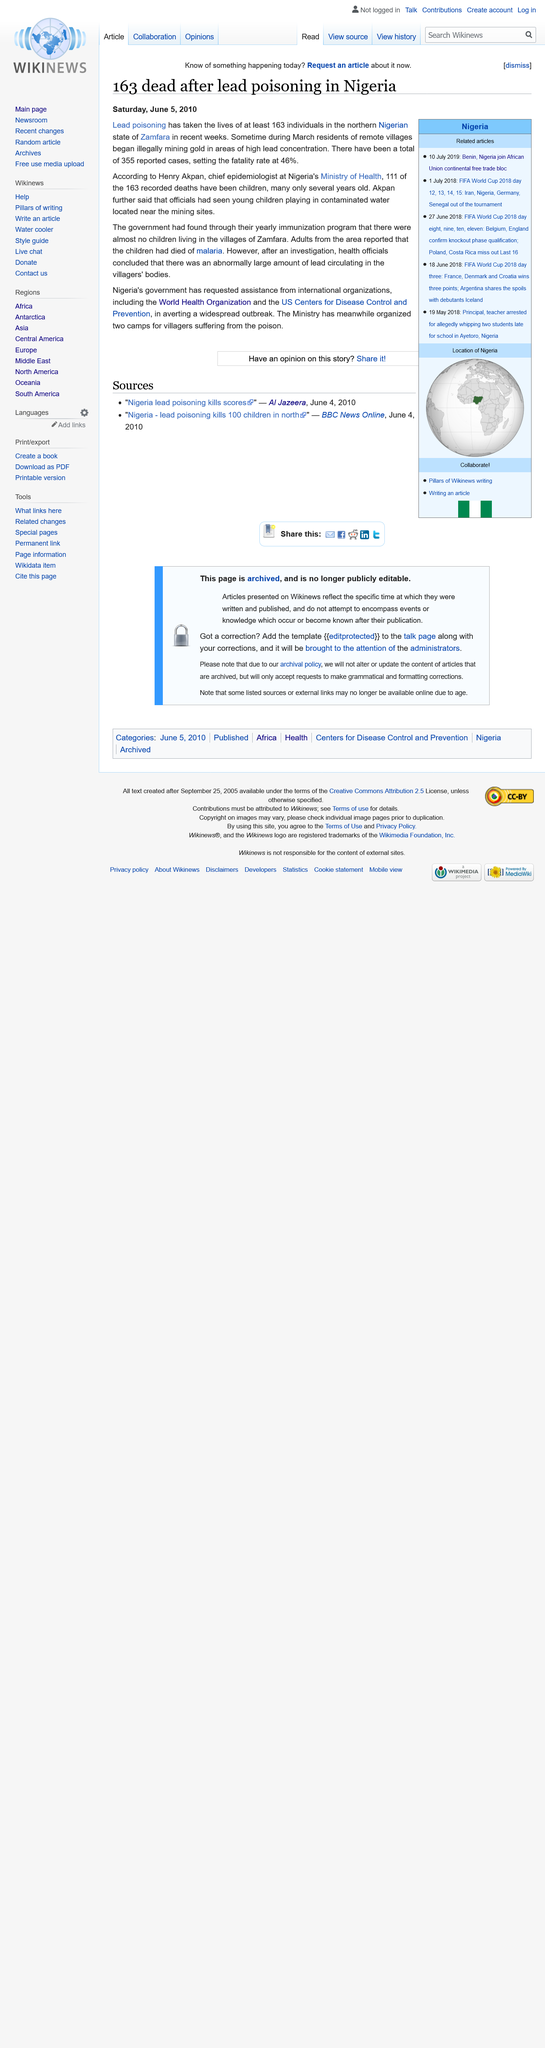Point out several critical features in this image. Lead contaminated the water near mining sites. Of the recorded deaths, a significant number, 111 specifically, have been children. Henry Akpan is the chief epidemiologist at the Ministry of Health in Nigeria. 